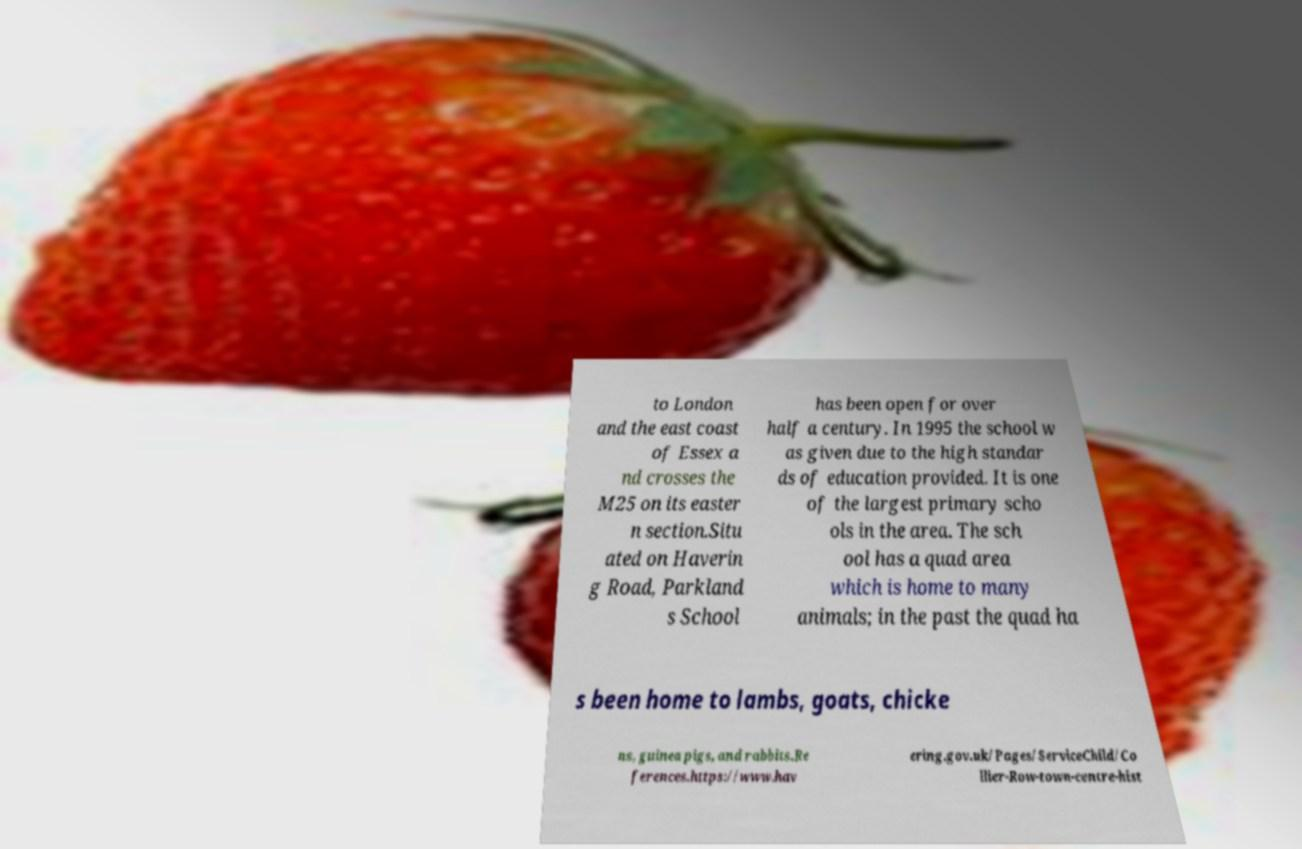There's text embedded in this image that I need extracted. Can you transcribe it verbatim? to London and the east coast of Essex a nd crosses the M25 on its easter n section.Situ ated on Haverin g Road, Parkland s School has been open for over half a century. In 1995 the school w as given due to the high standar ds of education provided. It is one of the largest primary scho ols in the area. The sch ool has a quad area which is home to many animals; in the past the quad ha s been home to lambs, goats, chicke ns, guinea pigs, and rabbits.Re ferences.https://www.hav ering.gov.uk/Pages/ServiceChild/Co llier-Row-town-centre-hist 